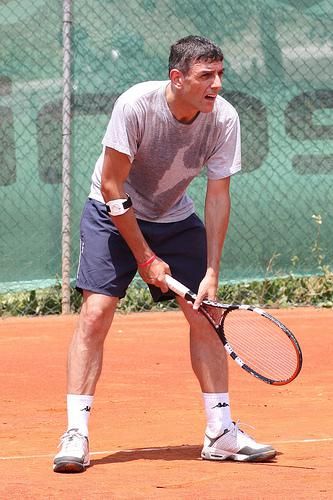Question: what color is handle on racket?
Choices:
A. Tan.
B. Black.
C. White.
D. Yellow.
Answer with the letter. Answer: A Question: who is playing tennis?
Choices:
A. Woman.
B. Two men.
C. The man.
D. Two women.
Answer with the letter. Answer: C Question: how is the man standing?
Choices:
A. Straight.
B. Askew.
C. Leaning.
D. Bent over.
Answer with the letter. Answer: D Question: what color are the man shorts?
Choices:
A. Green.
B. Red.
C. Blue.
D. White.
Answer with the letter. Answer: C Question: why is the man sweating?
Choices:
A. Tired out from run.
B. Workout from tennis.
C. Overheated from hot weather.
D. Stressed over meeting.
Answer with the letter. Answer: B Question: where is this man?
Choices:
A. Basketball court.
B. Gym.
C. Tennis court.
D. Showers.
Answer with the letter. Answer: C 